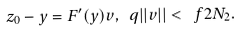<formula> <loc_0><loc_0><loc_500><loc_500>z _ { 0 } - y = F ^ { \prime } ( y ) v , \ q | | v | | < \ f { 2 } { N _ { 2 } } .</formula> 